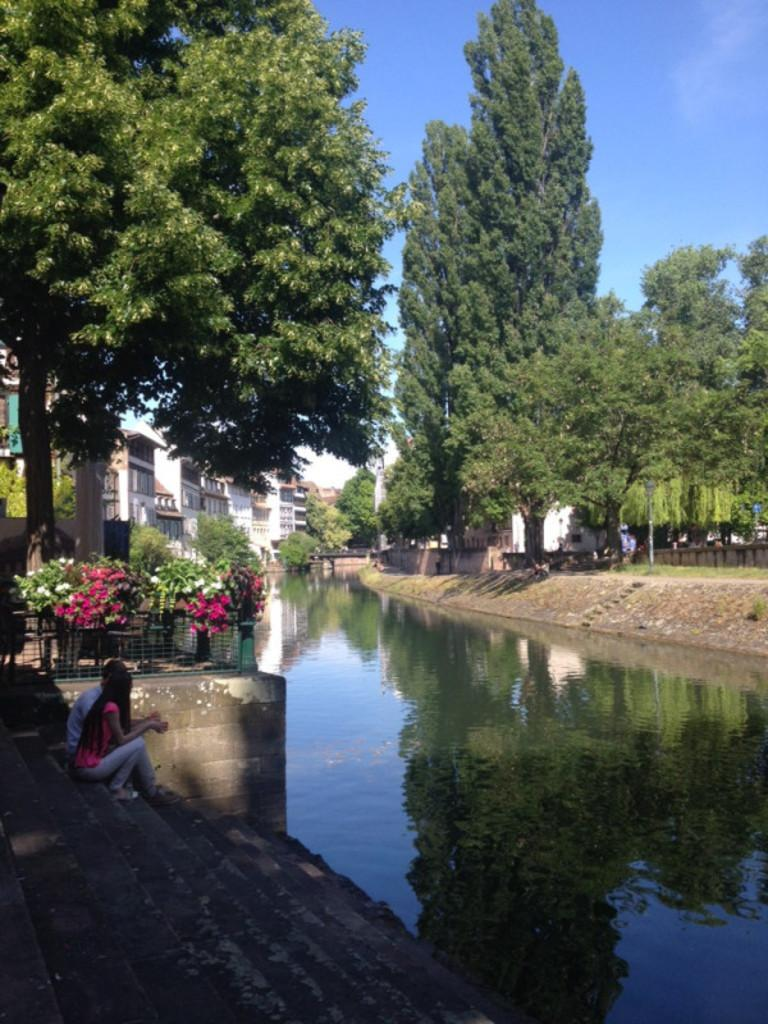What type of natural feature is present in the image? There is a lake in the image. What structures are located near the lake? There are buildings near the lake. What type of vegetation can be seen in the image? There are trees in the image. Can you describe the people in the image? Two people are sitting on stairs in the image. What type of plant is the cub playing with in the image? There is no plant or cub present in the image. How much debt do the people sitting on the stairs owe in the image? There is no information about debt in the image; it only shows two people sitting on stairs. 